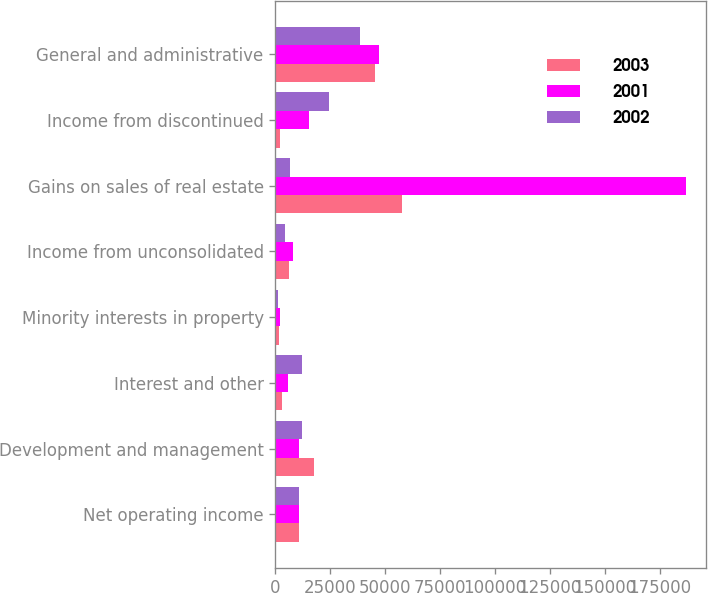<chart> <loc_0><loc_0><loc_500><loc_500><stacked_bar_chart><ecel><fcel>Net operating income<fcel>Development and management<fcel>Interest and other<fcel>Minority interests in property<fcel>Income from unconsolidated<fcel>Gains on sales of real estate<fcel>Income from discontinued<fcel>General and administrative<nl><fcel>2003<fcel>10748<fcel>17347<fcel>3033<fcel>1604<fcel>6016<fcel>57574<fcel>2176<fcel>45359<nl><fcel>2001<fcel>10748<fcel>10748<fcel>5504<fcel>2171<fcel>7954<fcel>186810<fcel>15310<fcel>47292<nl><fcel>2002<fcel>10748<fcel>12167<fcel>12183<fcel>1194<fcel>4186<fcel>6505<fcel>24512<fcel>38312<nl></chart> 